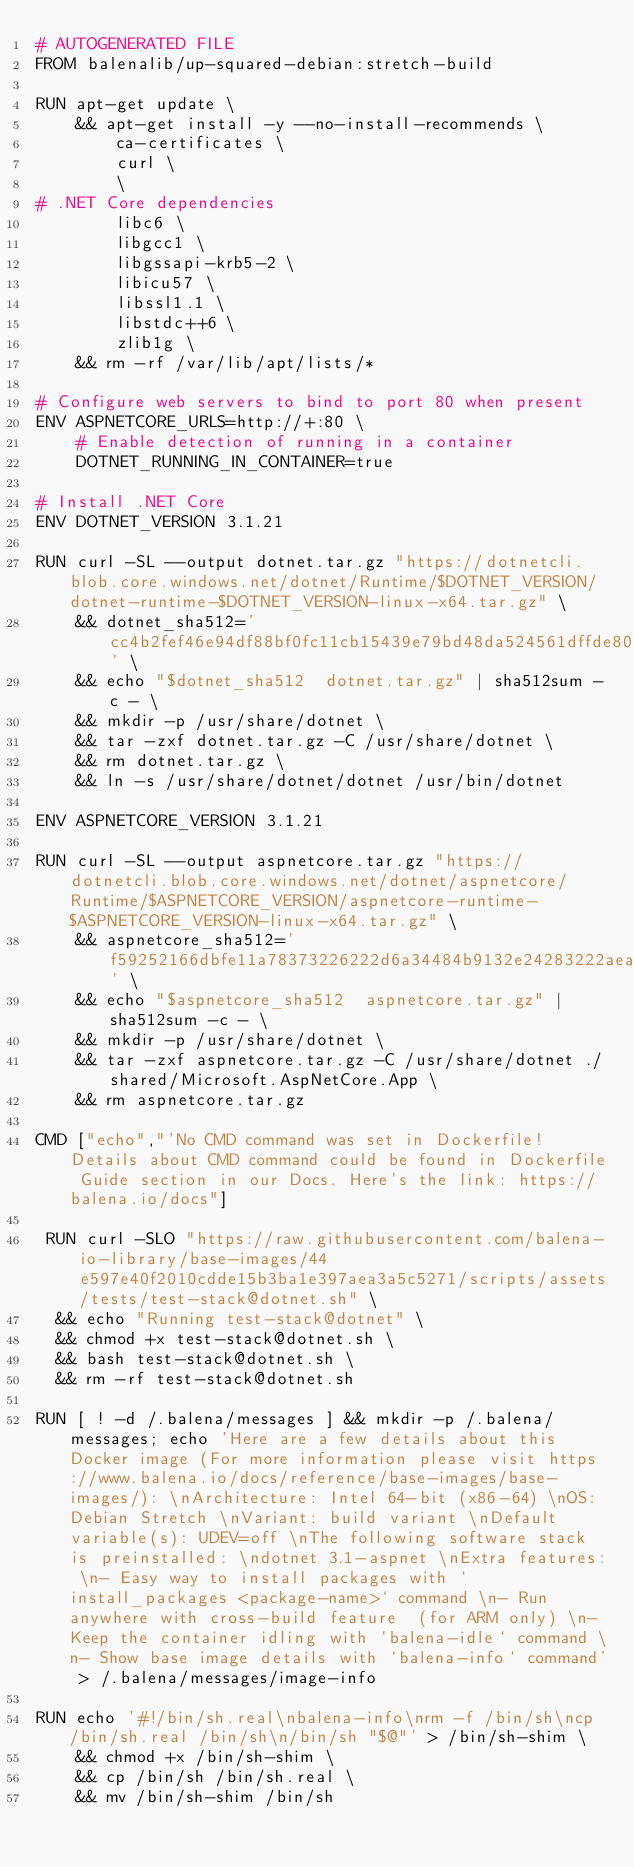Convert code to text. <code><loc_0><loc_0><loc_500><loc_500><_Dockerfile_># AUTOGENERATED FILE
FROM balenalib/up-squared-debian:stretch-build

RUN apt-get update \
    && apt-get install -y --no-install-recommends \
        ca-certificates \
        curl \
        \
# .NET Core dependencies
        libc6 \
        libgcc1 \
        libgssapi-krb5-2 \
        libicu57 \
        libssl1.1 \
        libstdc++6 \
        zlib1g \
    && rm -rf /var/lib/apt/lists/*

# Configure web servers to bind to port 80 when present
ENV ASPNETCORE_URLS=http://+:80 \
    # Enable detection of running in a container
    DOTNET_RUNNING_IN_CONTAINER=true

# Install .NET Core
ENV DOTNET_VERSION 3.1.21

RUN curl -SL --output dotnet.tar.gz "https://dotnetcli.blob.core.windows.net/dotnet/Runtime/$DOTNET_VERSION/dotnet-runtime-$DOTNET_VERSION-linux-x64.tar.gz" \
    && dotnet_sha512='cc4b2fef46e94df88bf0fc11cb15439e79bd48da524561dffde80d3cd6db218133468ad2f6785803cf0c13f000d95ff71eb258cec76dd8eb809676ec1cb38fac' \
    && echo "$dotnet_sha512  dotnet.tar.gz" | sha512sum -c - \
    && mkdir -p /usr/share/dotnet \
    && tar -zxf dotnet.tar.gz -C /usr/share/dotnet \
    && rm dotnet.tar.gz \
    && ln -s /usr/share/dotnet/dotnet /usr/bin/dotnet

ENV ASPNETCORE_VERSION 3.1.21

RUN curl -SL --output aspnetcore.tar.gz "https://dotnetcli.blob.core.windows.net/dotnet/aspnetcore/Runtime/$ASPNETCORE_VERSION/aspnetcore-runtime-$ASPNETCORE_VERSION-linux-x64.tar.gz" \
    && aspnetcore_sha512='f59252166dbfe11a78373226222d6a34484b9132e24283222aea8a950a5e9657da2e4d4e9ff8cbcc2fd7c7705e13bf42a31232a6012d1e247efc718e3d8e2df1' \
    && echo "$aspnetcore_sha512  aspnetcore.tar.gz" | sha512sum -c - \
    && mkdir -p /usr/share/dotnet \
    && tar -zxf aspnetcore.tar.gz -C /usr/share/dotnet ./shared/Microsoft.AspNetCore.App \
    && rm aspnetcore.tar.gz

CMD ["echo","'No CMD command was set in Dockerfile! Details about CMD command could be found in Dockerfile Guide section in our Docs. Here's the link: https://balena.io/docs"]

 RUN curl -SLO "https://raw.githubusercontent.com/balena-io-library/base-images/44e597e40f2010cdde15b3ba1e397aea3a5c5271/scripts/assets/tests/test-stack@dotnet.sh" \
  && echo "Running test-stack@dotnet" \
  && chmod +x test-stack@dotnet.sh \
  && bash test-stack@dotnet.sh \
  && rm -rf test-stack@dotnet.sh 

RUN [ ! -d /.balena/messages ] && mkdir -p /.balena/messages; echo 'Here are a few details about this Docker image (For more information please visit https://www.balena.io/docs/reference/base-images/base-images/): \nArchitecture: Intel 64-bit (x86-64) \nOS: Debian Stretch \nVariant: build variant \nDefault variable(s): UDEV=off \nThe following software stack is preinstalled: \ndotnet 3.1-aspnet \nExtra features: \n- Easy way to install packages with `install_packages <package-name>` command \n- Run anywhere with cross-build feature  (for ARM only) \n- Keep the container idling with `balena-idle` command \n- Show base image details with `balena-info` command' > /.balena/messages/image-info

RUN echo '#!/bin/sh.real\nbalena-info\nrm -f /bin/sh\ncp /bin/sh.real /bin/sh\n/bin/sh "$@"' > /bin/sh-shim \
	&& chmod +x /bin/sh-shim \
	&& cp /bin/sh /bin/sh.real \
	&& mv /bin/sh-shim /bin/sh</code> 